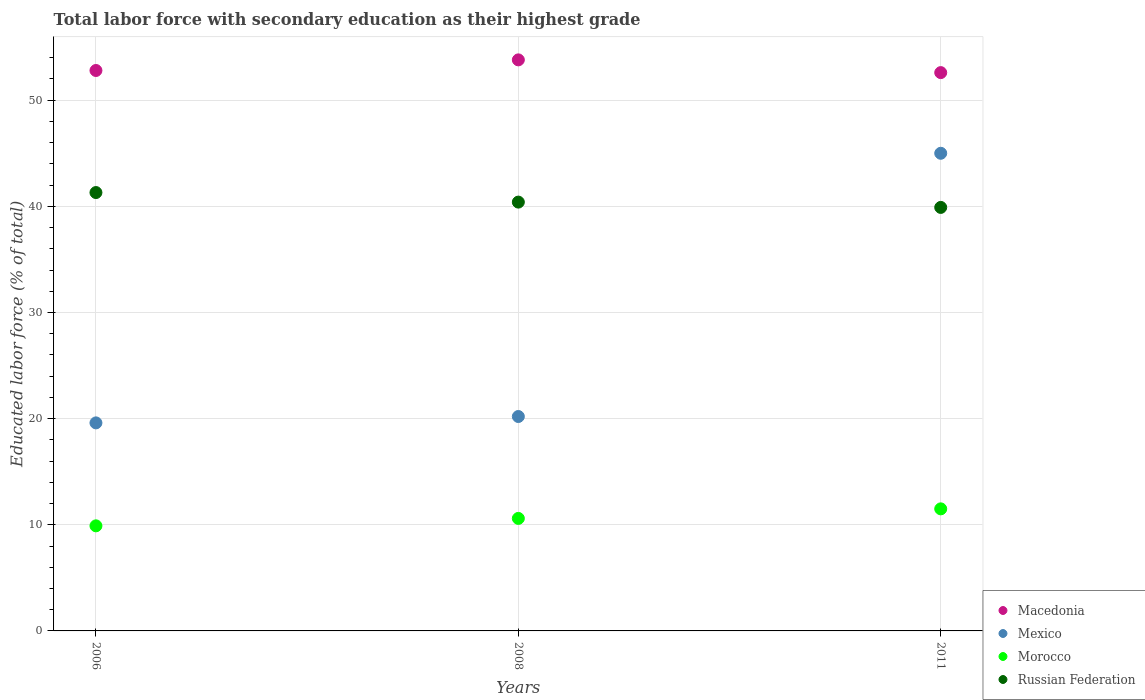How many different coloured dotlines are there?
Offer a very short reply. 4. What is the percentage of total labor force with primary education in Morocco in 2008?
Give a very brief answer. 10.6. Across all years, what is the maximum percentage of total labor force with primary education in Mexico?
Make the answer very short. 45. Across all years, what is the minimum percentage of total labor force with primary education in Morocco?
Your response must be concise. 9.9. In which year was the percentage of total labor force with primary education in Mexico maximum?
Make the answer very short. 2011. In which year was the percentage of total labor force with primary education in Morocco minimum?
Your answer should be compact. 2006. What is the total percentage of total labor force with primary education in Russian Federation in the graph?
Keep it short and to the point. 121.6. What is the difference between the percentage of total labor force with primary education in Russian Federation in 2006 and the percentage of total labor force with primary education in Macedonia in 2008?
Your answer should be compact. -12.5. What is the average percentage of total labor force with primary education in Morocco per year?
Your answer should be compact. 10.67. In the year 2011, what is the difference between the percentage of total labor force with primary education in Morocco and percentage of total labor force with primary education in Mexico?
Ensure brevity in your answer.  -33.5. In how many years, is the percentage of total labor force with primary education in Macedonia greater than 2 %?
Give a very brief answer. 3. What is the ratio of the percentage of total labor force with primary education in Mexico in 2006 to that in 2011?
Offer a terse response. 0.44. What is the difference between the highest and the second highest percentage of total labor force with primary education in Morocco?
Make the answer very short. 0.9. What is the difference between the highest and the lowest percentage of total labor force with primary education in Morocco?
Your answer should be compact. 1.6. Is it the case that in every year, the sum of the percentage of total labor force with primary education in Mexico and percentage of total labor force with primary education in Russian Federation  is greater than the sum of percentage of total labor force with primary education in Macedonia and percentage of total labor force with primary education in Morocco?
Your answer should be compact. No. Is it the case that in every year, the sum of the percentage of total labor force with primary education in Russian Federation and percentage of total labor force with primary education in Morocco  is greater than the percentage of total labor force with primary education in Mexico?
Offer a terse response. Yes. Is the percentage of total labor force with primary education in Russian Federation strictly greater than the percentage of total labor force with primary education in Macedonia over the years?
Offer a very short reply. No. Is the percentage of total labor force with primary education in Russian Federation strictly less than the percentage of total labor force with primary education in Mexico over the years?
Provide a succinct answer. No. How many dotlines are there?
Give a very brief answer. 4. How many years are there in the graph?
Your answer should be very brief. 3. Are the values on the major ticks of Y-axis written in scientific E-notation?
Your answer should be compact. No. Does the graph contain any zero values?
Provide a succinct answer. No. How many legend labels are there?
Provide a succinct answer. 4. What is the title of the graph?
Your answer should be very brief. Total labor force with secondary education as their highest grade. Does "Bangladesh" appear as one of the legend labels in the graph?
Provide a succinct answer. No. What is the label or title of the X-axis?
Offer a very short reply. Years. What is the label or title of the Y-axis?
Your response must be concise. Educated labor force (% of total). What is the Educated labor force (% of total) of Macedonia in 2006?
Offer a terse response. 52.8. What is the Educated labor force (% of total) of Mexico in 2006?
Ensure brevity in your answer.  19.6. What is the Educated labor force (% of total) of Morocco in 2006?
Your response must be concise. 9.9. What is the Educated labor force (% of total) of Russian Federation in 2006?
Offer a terse response. 41.3. What is the Educated labor force (% of total) in Macedonia in 2008?
Offer a terse response. 53.8. What is the Educated labor force (% of total) in Mexico in 2008?
Offer a very short reply. 20.2. What is the Educated labor force (% of total) in Morocco in 2008?
Give a very brief answer. 10.6. What is the Educated labor force (% of total) in Russian Federation in 2008?
Your answer should be compact. 40.4. What is the Educated labor force (% of total) in Macedonia in 2011?
Ensure brevity in your answer.  52.6. What is the Educated labor force (% of total) of Russian Federation in 2011?
Your answer should be compact. 39.9. Across all years, what is the maximum Educated labor force (% of total) of Macedonia?
Your answer should be very brief. 53.8. Across all years, what is the maximum Educated labor force (% of total) in Mexico?
Give a very brief answer. 45. Across all years, what is the maximum Educated labor force (% of total) in Russian Federation?
Your answer should be compact. 41.3. Across all years, what is the minimum Educated labor force (% of total) in Macedonia?
Provide a short and direct response. 52.6. Across all years, what is the minimum Educated labor force (% of total) of Mexico?
Make the answer very short. 19.6. Across all years, what is the minimum Educated labor force (% of total) in Morocco?
Provide a succinct answer. 9.9. Across all years, what is the minimum Educated labor force (% of total) in Russian Federation?
Offer a terse response. 39.9. What is the total Educated labor force (% of total) of Macedonia in the graph?
Give a very brief answer. 159.2. What is the total Educated labor force (% of total) of Mexico in the graph?
Keep it short and to the point. 84.8. What is the total Educated labor force (% of total) of Morocco in the graph?
Make the answer very short. 32. What is the total Educated labor force (% of total) of Russian Federation in the graph?
Make the answer very short. 121.6. What is the difference between the Educated labor force (% of total) of Mexico in 2006 and that in 2008?
Provide a succinct answer. -0.6. What is the difference between the Educated labor force (% of total) in Morocco in 2006 and that in 2008?
Offer a very short reply. -0.7. What is the difference between the Educated labor force (% of total) in Mexico in 2006 and that in 2011?
Offer a very short reply. -25.4. What is the difference between the Educated labor force (% of total) of Morocco in 2006 and that in 2011?
Give a very brief answer. -1.6. What is the difference between the Educated labor force (% of total) of Russian Federation in 2006 and that in 2011?
Your response must be concise. 1.4. What is the difference between the Educated labor force (% of total) in Mexico in 2008 and that in 2011?
Your answer should be very brief. -24.8. What is the difference between the Educated labor force (% of total) in Morocco in 2008 and that in 2011?
Your response must be concise. -0.9. What is the difference between the Educated labor force (% of total) in Russian Federation in 2008 and that in 2011?
Keep it short and to the point. 0.5. What is the difference between the Educated labor force (% of total) in Macedonia in 2006 and the Educated labor force (% of total) in Mexico in 2008?
Ensure brevity in your answer.  32.6. What is the difference between the Educated labor force (% of total) in Macedonia in 2006 and the Educated labor force (% of total) in Morocco in 2008?
Your answer should be compact. 42.2. What is the difference between the Educated labor force (% of total) in Macedonia in 2006 and the Educated labor force (% of total) in Russian Federation in 2008?
Your answer should be compact. 12.4. What is the difference between the Educated labor force (% of total) in Mexico in 2006 and the Educated labor force (% of total) in Russian Federation in 2008?
Keep it short and to the point. -20.8. What is the difference between the Educated labor force (% of total) in Morocco in 2006 and the Educated labor force (% of total) in Russian Federation in 2008?
Give a very brief answer. -30.5. What is the difference between the Educated labor force (% of total) of Macedonia in 2006 and the Educated labor force (% of total) of Mexico in 2011?
Provide a short and direct response. 7.8. What is the difference between the Educated labor force (% of total) in Macedonia in 2006 and the Educated labor force (% of total) in Morocco in 2011?
Provide a short and direct response. 41.3. What is the difference between the Educated labor force (% of total) of Mexico in 2006 and the Educated labor force (% of total) of Russian Federation in 2011?
Provide a short and direct response. -20.3. What is the difference between the Educated labor force (% of total) of Macedonia in 2008 and the Educated labor force (% of total) of Mexico in 2011?
Provide a succinct answer. 8.8. What is the difference between the Educated labor force (% of total) of Macedonia in 2008 and the Educated labor force (% of total) of Morocco in 2011?
Offer a terse response. 42.3. What is the difference between the Educated labor force (% of total) of Mexico in 2008 and the Educated labor force (% of total) of Russian Federation in 2011?
Make the answer very short. -19.7. What is the difference between the Educated labor force (% of total) in Morocco in 2008 and the Educated labor force (% of total) in Russian Federation in 2011?
Offer a very short reply. -29.3. What is the average Educated labor force (% of total) in Macedonia per year?
Keep it short and to the point. 53.07. What is the average Educated labor force (% of total) in Mexico per year?
Your answer should be very brief. 28.27. What is the average Educated labor force (% of total) in Morocco per year?
Offer a very short reply. 10.67. What is the average Educated labor force (% of total) of Russian Federation per year?
Keep it short and to the point. 40.53. In the year 2006, what is the difference between the Educated labor force (% of total) of Macedonia and Educated labor force (% of total) of Mexico?
Make the answer very short. 33.2. In the year 2006, what is the difference between the Educated labor force (% of total) of Macedonia and Educated labor force (% of total) of Morocco?
Your response must be concise. 42.9. In the year 2006, what is the difference between the Educated labor force (% of total) in Macedonia and Educated labor force (% of total) in Russian Federation?
Keep it short and to the point. 11.5. In the year 2006, what is the difference between the Educated labor force (% of total) of Mexico and Educated labor force (% of total) of Russian Federation?
Your answer should be compact. -21.7. In the year 2006, what is the difference between the Educated labor force (% of total) of Morocco and Educated labor force (% of total) of Russian Federation?
Your answer should be very brief. -31.4. In the year 2008, what is the difference between the Educated labor force (% of total) of Macedonia and Educated labor force (% of total) of Mexico?
Your answer should be very brief. 33.6. In the year 2008, what is the difference between the Educated labor force (% of total) of Macedonia and Educated labor force (% of total) of Morocco?
Ensure brevity in your answer.  43.2. In the year 2008, what is the difference between the Educated labor force (% of total) of Mexico and Educated labor force (% of total) of Morocco?
Offer a terse response. 9.6. In the year 2008, what is the difference between the Educated labor force (% of total) in Mexico and Educated labor force (% of total) in Russian Federation?
Your response must be concise. -20.2. In the year 2008, what is the difference between the Educated labor force (% of total) in Morocco and Educated labor force (% of total) in Russian Federation?
Provide a short and direct response. -29.8. In the year 2011, what is the difference between the Educated labor force (% of total) in Macedonia and Educated labor force (% of total) in Mexico?
Your answer should be compact. 7.6. In the year 2011, what is the difference between the Educated labor force (% of total) in Macedonia and Educated labor force (% of total) in Morocco?
Your response must be concise. 41.1. In the year 2011, what is the difference between the Educated labor force (% of total) of Macedonia and Educated labor force (% of total) of Russian Federation?
Your answer should be compact. 12.7. In the year 2011, what is the difference between the Educated labor force (% of total) of Mexico and Educated labor force (% of total) of Morocco?
Ensure brevity in your answer.  33.5. In the year 2011, what is the difference between the Educated labor force (% of total) of Mexico and Educated labor force (% of total) of Russian Federation?
Your answer should be very brief. 5.1. In the year 2011, what is the difference between the Educated labor force (% of total) in Morocco and Educated labor force (% of total) in Russian Federation?
Your response must be concise. -28.4. What is the ratio of the Educated labor force (% of total) in Macedonia in 2006 to that in 2008?
Make the answer very short. 0.98. What is the ratio of the Educated labor force (% of total) in Mexico in 2006 to that in 2008?
Your answer should be very brief. 0.97. What is the ratio of the Educated labor force (% of total) in Morocco in 2006 to that in 2008?
Give a very brief answer. 0.93. What is the ratio of the Educated labor force (% of total) of Russian Federation in 2006 to that in 2008?
Offer a terse response. 1.02. What is the ratio of the Educated labor force (% of total) of Macedonia in 2006 to that in 2011?
Your answer should be very brief. 1. What is the ratio of the Educated labor force (% of total) of Mexico in 2006 to that in 2011?
Provide a short and direct response. 0.44. What is the ratio of the Educated labor force (% of total) of Morocco in 2006 to that in 2011?
Give a very brief answer. 0.86. What is the ratio of the Educated labor force (% of total) of Russian Federation in 2006 to that in 2011?
Offer a terse response. 1.04. What is the ratio of the Educated labor force (% of total) in Macedonia in 2008 to that in 2011?
Ensure brevity in your answer.  1.02. What is the ratio of the Educated labor force (% of total) of Mexico in 2008 to that in 2011?
Offer a terse response. 0.45. What is the ratio of the Educated labor force (% of total) of Morocco in 2008 to that in 2011?
Provide a succinct answer. 0.92. What is the ratio of the Educated labor force (% of total) in Russian Federation in 2008 to that in 2011?
Keep it short and to the point. 1.01. What is the difference between the highest and the second highest Educated labor force (% of total) of Mexico?
Give a very brief answer. 24.8. What is the difference between the highest and the second highest Educated labor force (% of total) of Morocco?
Your response must be concise. 0.9. What is the difference between the highest and the second highest Educated labor force (% of total) in Russian Federation?
Give a very brief answer. 0.9. What is the difference between the highest and the lowest Educated labor force (% of total) of Macedonia?
Keep it short and to the point. 1.2. What is the difference between the highest and the lowest Educated labor force (% of total) in Mexico?
Give a very brief answer. 25.4. 